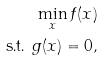<formula> <loc_0><loc_0><loc_500><loc_500>\min _ { x } f ( x ) \\ \text { s.t. } g ( x ) = 0 ,</formula> 